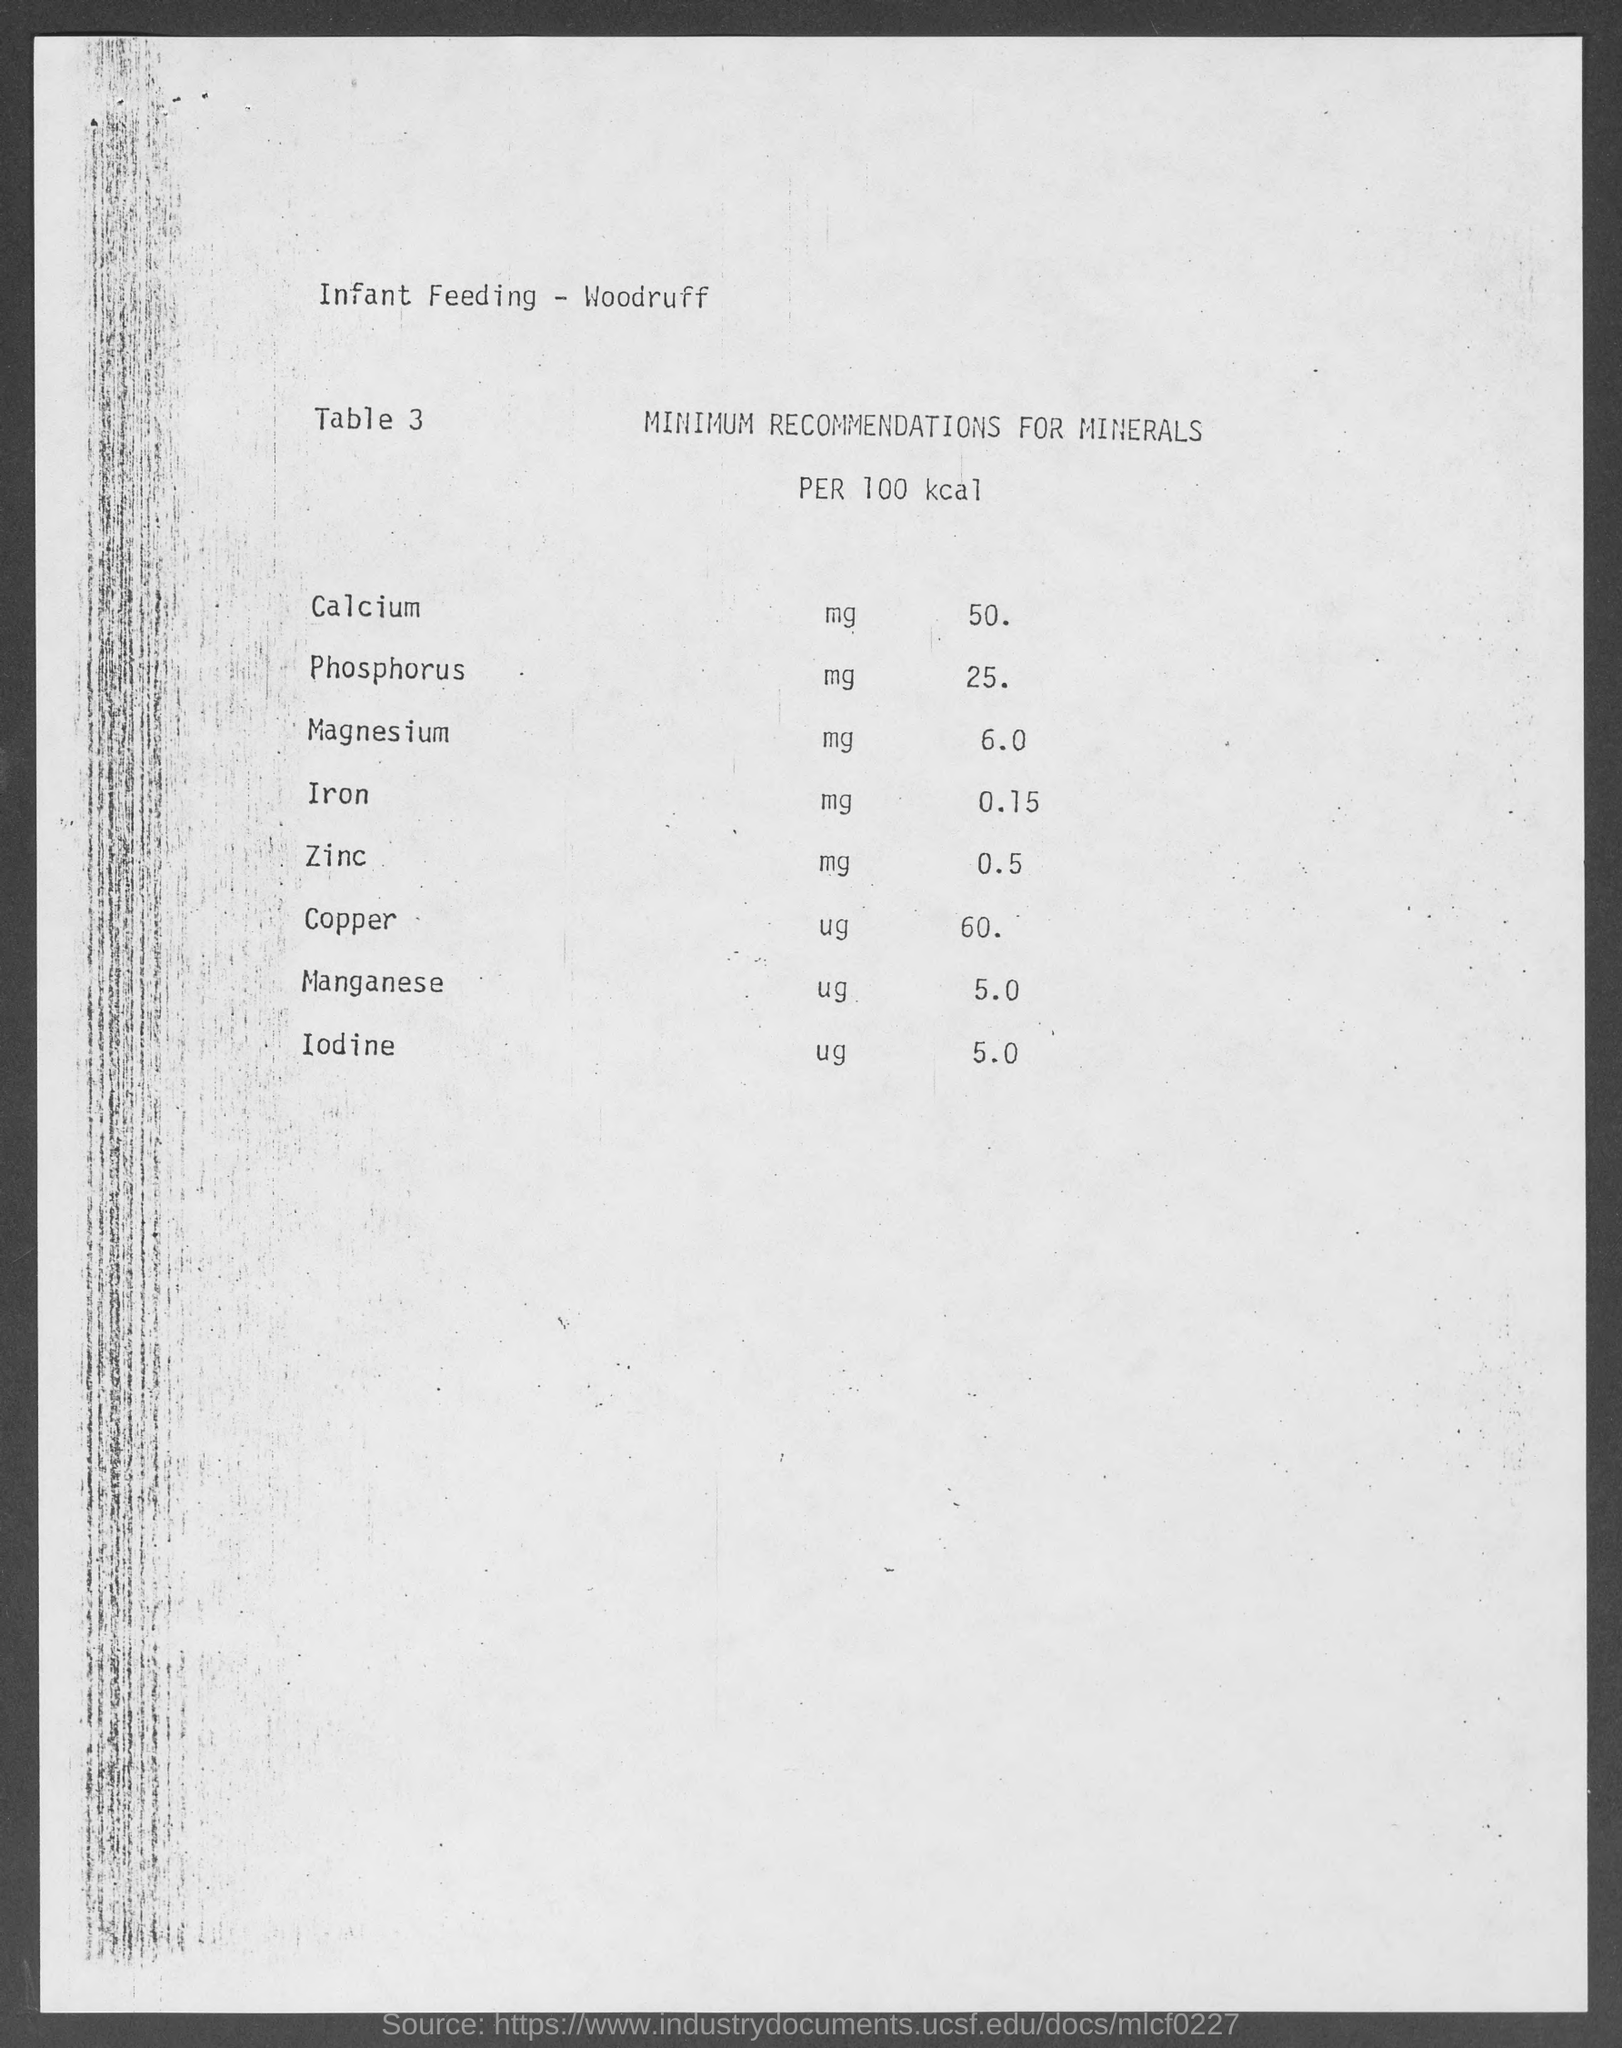Point out several critical features in this image. The recommended minimum intake of magnesium per 100 calories is 6.0 milligrams. The recommended minimum intake of zinc per 100 Kcal is 0.5 milligrams. According to the recommended daily intake of manganese, an adult should consume at least 5.0 mg of manganese per 100 Kcal. The recommended minimum intake of phosphorous per 100 calories is 25 milligrams. The recommended minimum intake of copper per 100 Kcal is 60 micrograms. 